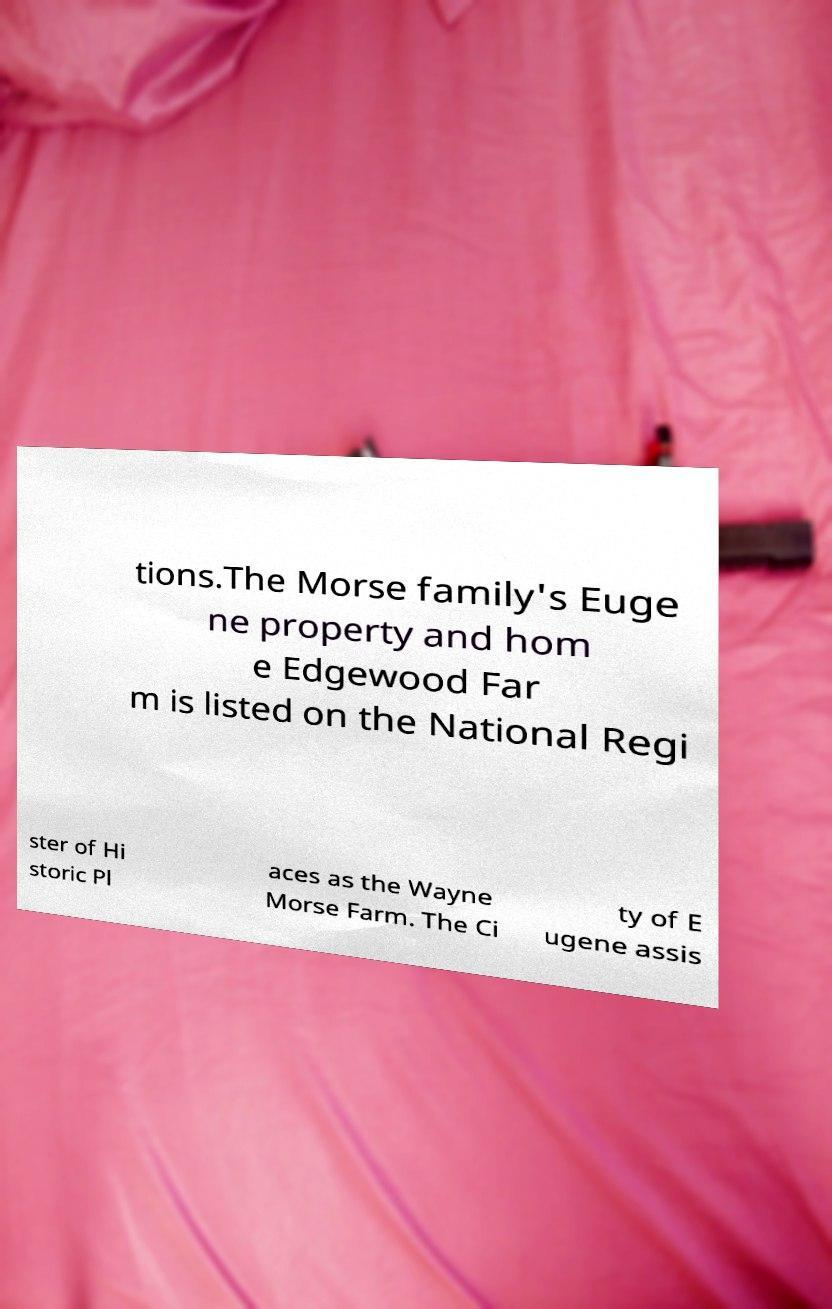Please read and relay the text visible in this image. What does it say? tions.The Morse family's Euge ne property and hom e Edgewood Far m is listed on the National Regi ster of Hi storic Pl aces as the Wayne Morse Farm. The Ci ty of E ugene assis 